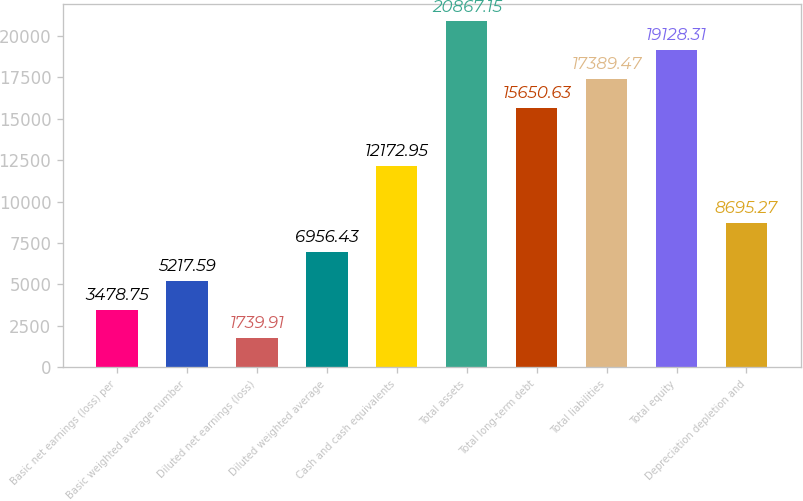Convert chart. <chart><loc_0><loc_0><loc_500><loc_500><bar_chart><fcel>Basic net earnings (loss) per<fcel>Basic weighted average number<fcel>Diluted net earnings (loss)<fcel>Diluted weighted average<fcel>Cash and cash equivalents<fcel>Total assets<fcel>Total long-term debt<fcel>Total liabilities<fcel>Total equity<fcel>Depreciation depletion and<nl><fcel>3478.75<fcel>5217.59<fcel>1739.91<fcel>6956.43<fcel>12173<fcel>20867.2<fcel>15650.6<fcel>17389.5<fcel>19128.3<fcel>8695.27<nl></chart> 